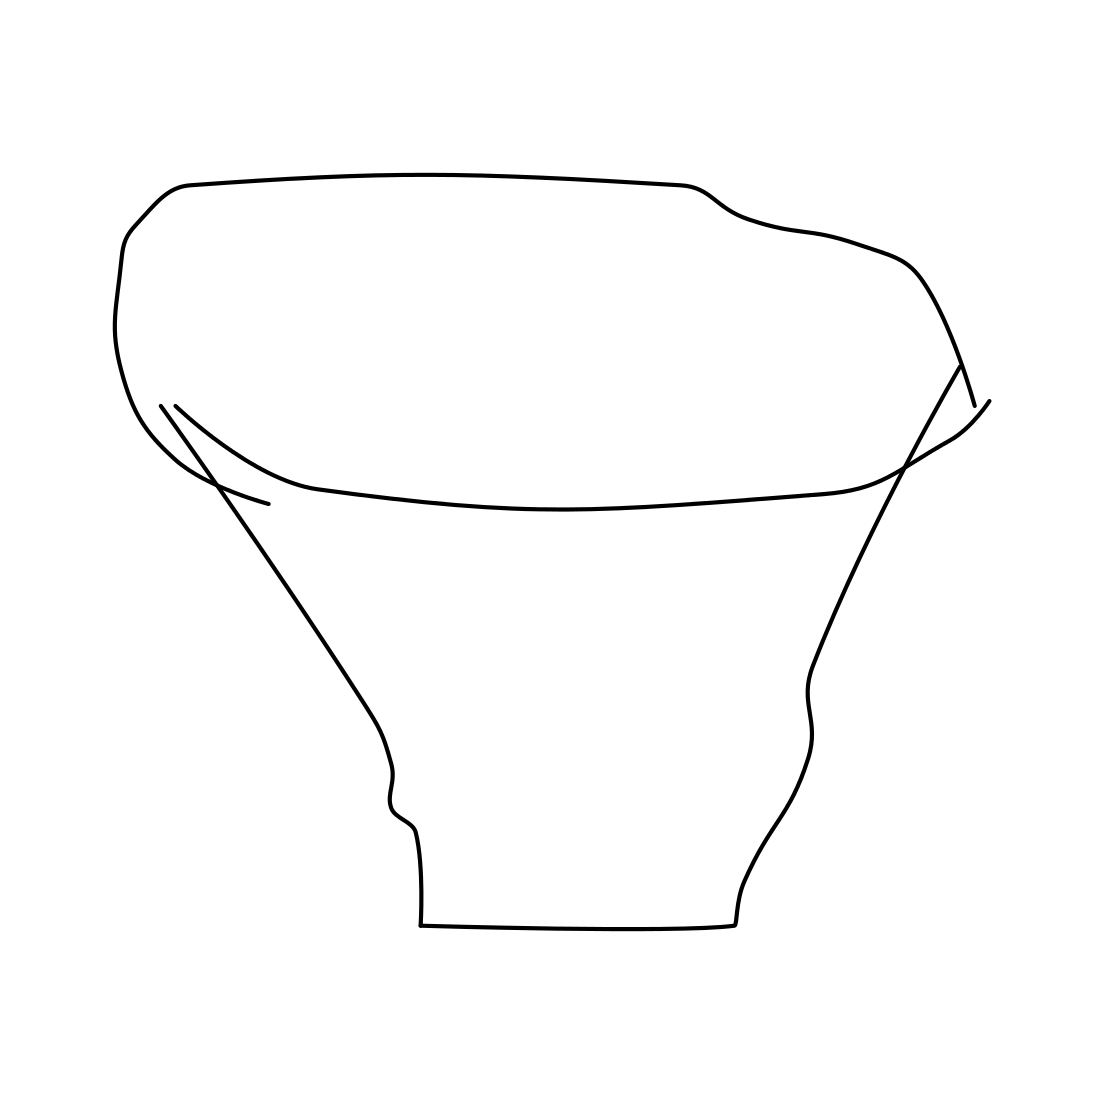In the scene, is an angel in it? No 